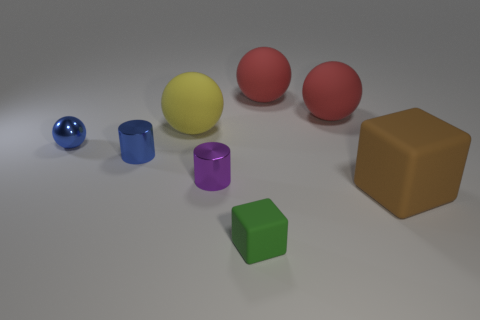What is the size of the green thing that is the same material as the big yellow sphere?
Provide a short and direct response. Small. There is a thing on the left side of the blue shiny cylinder; is its size the same as the brown object?
Give a very brief answer. No. What number of large red things are to the right of the big sphere left of the green thing?
Offer a terse response. 2. Are there fewer small rubber things that are behind the tiny cube than small shiny spheres?
Provide a succinct answer. Yes. Is there a big red matte object on the left side of the metal object to the right of the big matte ball that is left of the purple metallic cylinder?
Provide a succinct answer. No. Is the material of the brown cube the same as the purple object to the left of the small cube?
Provide a short and direct response. No. There is a big block that is in front of the blue ball that is on the left side of the tiny green object; what is its color?
Provide a succinct answer. Brown. Are there any cubes that have the same color as the tiny shiny ball?
Your response must be concise. No. How big is the object that is in front of the large object in front of the large matte thing on the left side of the tiny matte object?
Offer a terse response. Small. There is a green rubber thing; is its shape the same as the big matte thing that is to the left of the tiny green rubber thing?
Your answer should be compact. No. 